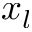<formula> <loc_0><loc_0><loc_500><loc_500>x _ { l }</formula> 